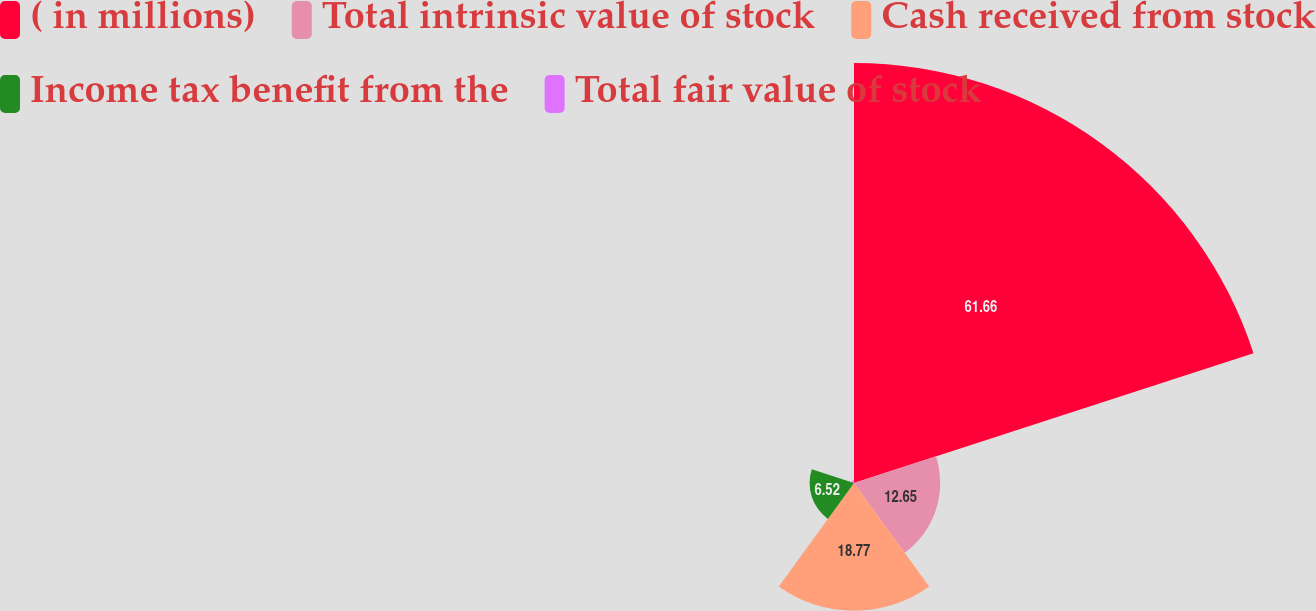Convert chart to OTSL. <chart><loc_0><loc_0><loc_500><loc_500><pie_chart><fcel>( in millions)<fcel>Total intrinsic value of stock<fcel>Cash received from stock<fcel>Income tax benefit from the<fcel>Total fair value of stock<nl><fcel>61.66%<fcel>12.65%<fcel>18.77%<fcel>6.52%<fcel>0.4%<nl></chart> 